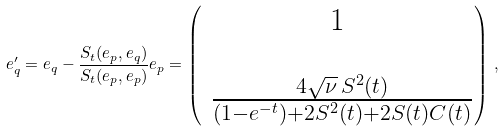Convert formula to latex. <formula><loc_0><loc_0><loc_500><loc_500>e _ { q } ^ { \prime } = e _ { q } - \frac { S _ { t } ( e _ { p } , e _ { q } ) } { S _ { t } ( e _ { p } , e _ { p } ) } e _ { p } = \begin{pmatrix} 1 \\ \\ \ \frac { 4 \sqrt { \nu } \, S ^ { 2 } ( t ) } { ( 1 - e ^ { - t } ) + 2 S ^ { 2 } ( t ) + 2 S ( t ) C ( t ) } \end{pmatrix} \, ,</formula> 